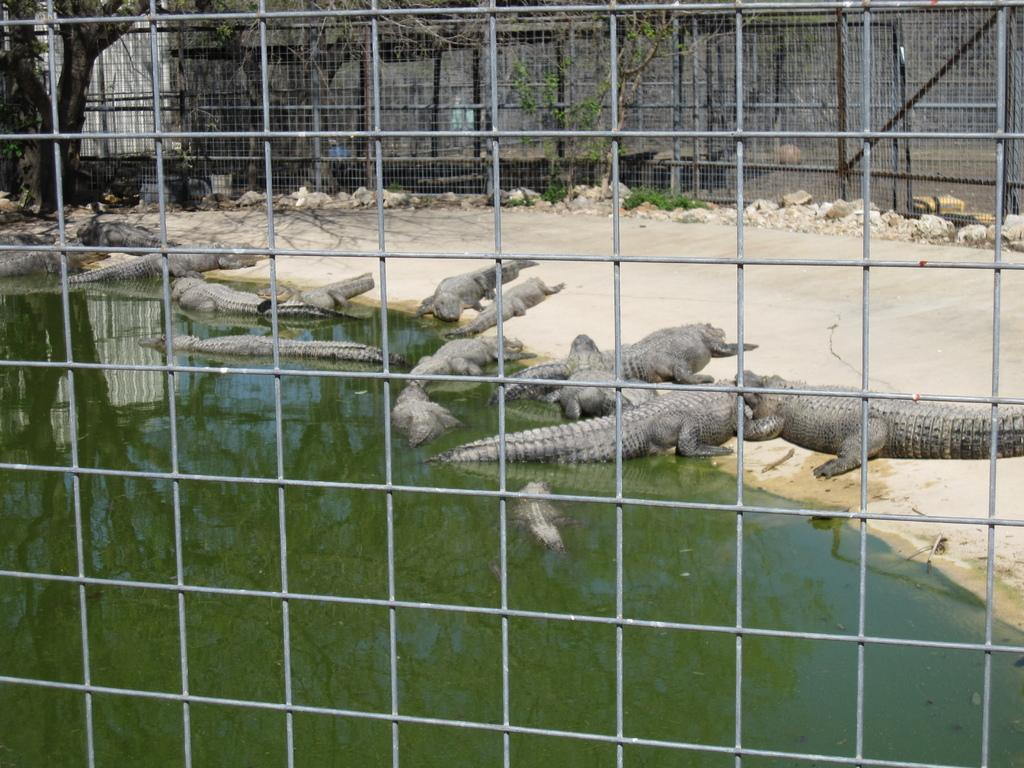What type of barrier can be seen in the image? There is a fence in the image. What animals are present in the image? There are crocodiles in the image. What natural element is visible in the image? There is water visible in the image. What type of plant life is present in the image? Tree trunks are present in the image. What geological feature can be seen in the image? Rocks are visible in the image. Who is the boy credited with taking the photograph in the image? There is no boy or credit information present in the image. What type of frame surrounds the image? The image does not show a frame; it only displays the content within the frame. 